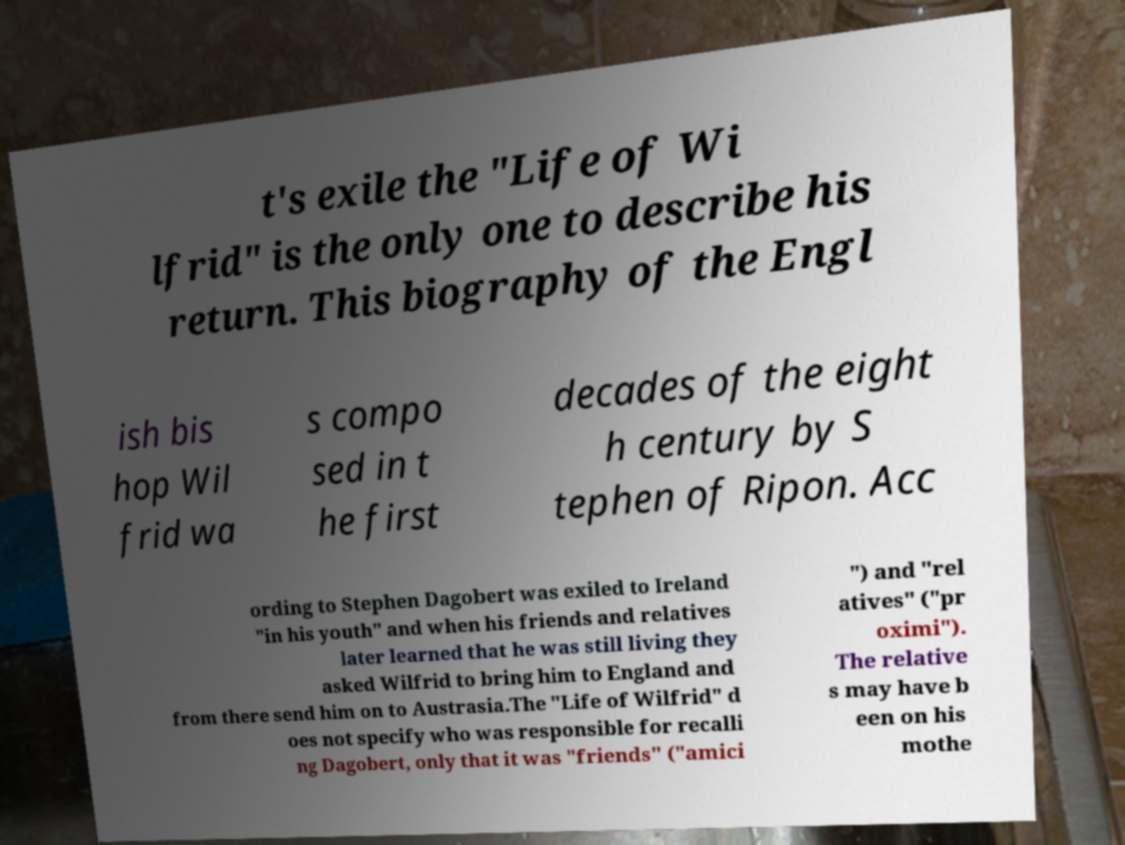What messages or text are displayed in this image? I need them in a readable, typed format. t's exile the "Life of Wi lfrid" is the only one to describe his return. This biography of the Engl ish bis hop Wil frid wa s compo sed in t he first decades of the eight h century by S tephen of Ripon. Acc ording to Stephen Dagobert was exiled to Ireland "in his youth" and when his friends and relatives later learned that he was still living they asked Wilfrid to bring him to England and from there send him on to Austrasia.The "Life of Wilfrid" d oes not specify who was responsible for recalli ng Dagobert, only that it was "friends" ("amici ") and "rel atives" ("pr oximi"). The relative s may have b een on his mothe 